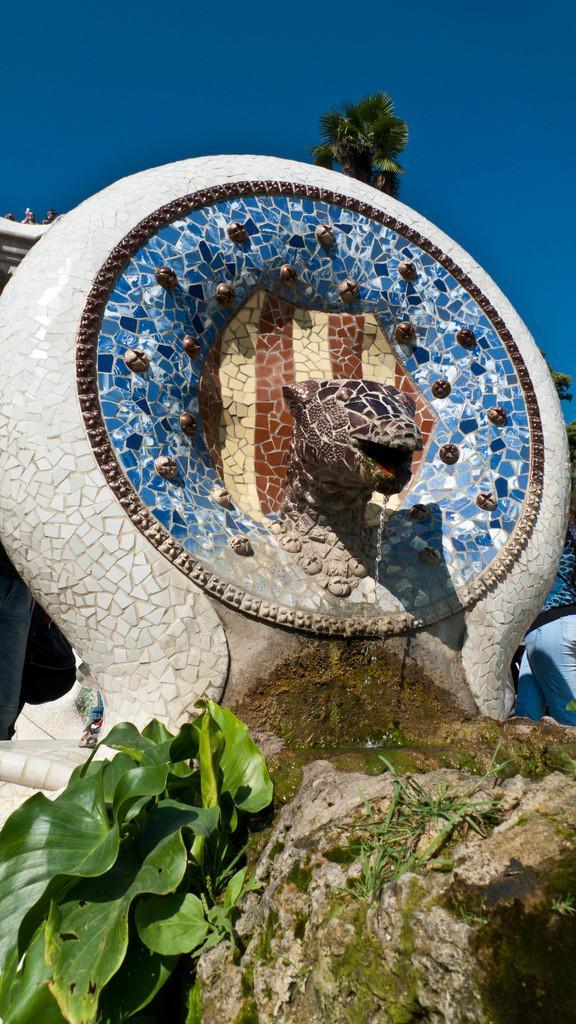Please provide a concise description of this image. In the image there is a round shaped wall with a statue of an animal's head. And also there is some design on it. From the statue's mouth there is water flowing. And on the ground there is grass and also there are leaves. In the background there is a tree. At the top of the image there is sky.  